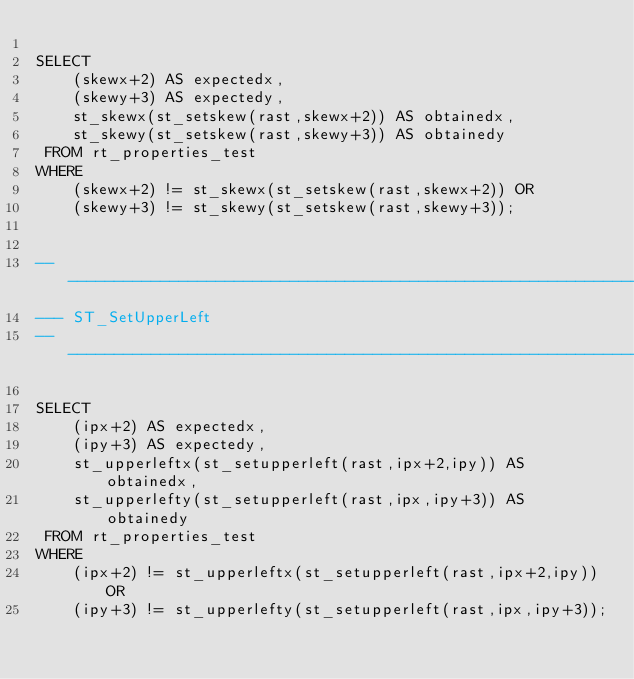<code> <loc_0><loc_0><loc_500><loc_500><_SQL_>
SELECT
    (skewx+2) AS expectedx,
    (skewy+3) AS expectedy,
    st_skewx(st_setskew(rast,skewx+2)) AS obtainedx,
    st_skewy(st_setskew(rast,skewy+3)) AS obtainedy
 FROM rt_properties_test
WHERE
    (skewx+2) != st_skewx(st_setskew(rast,skewx+2)) OR
    (skewy+3) != st_skewy(st_setskew(rast,skewy+3));


-----------------------------------------------------------------------
--- ST_SetUpperLeft
-----------------------------------------------------------------------

SELECT
    (ipx+2) AS expectedx,
    (ipy+3) AS expectedy,
    st_upperleftx(st_setupperleft(rast,ipx+2,ipy)) AS obtainedx,
    st_upperlefty(st_setupperleft(rast,ipx,ipy+3)) AS obtainedy
 FROM rt_properties_test
WHERE
    (ipx+2) != st_upperleftx(st_setupperleft(rast,ipx+2,ipy)) OR
    (ipy+3) != st_upperlefty(st_setupperleft(rast,ipx,ipy+3));
</code> 